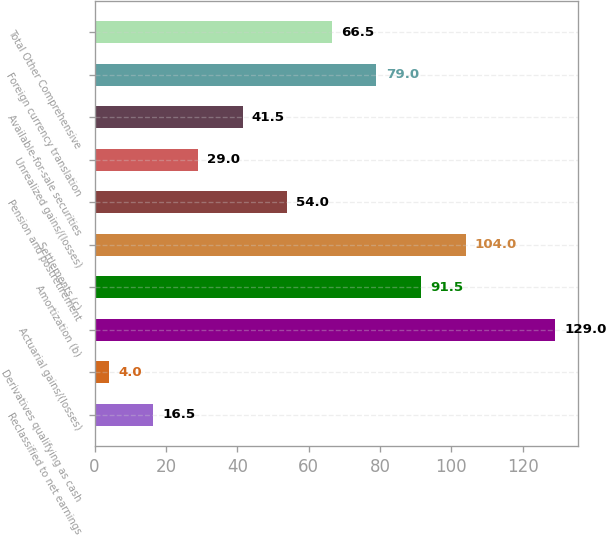Convert chart. <chart><loc_0><loc_0><loc_500><loc_500><bar_chart><fcel>Reclassified to net earnings<fcel>Derivatives qualifying as cash<fcel>Actuarial gains/(losses)<fcel>Amortization (b)<fcel>Settlements (c)<fcel>Pension and postretirement<fcel>Unrealized gains/(losses)<fcel>Available-for-sale securities<fcel>Foreign currency translation<fcel>Total Other Comprehensive<nl><fcel>16.5<fcel>4<fcel>129<fcel>91.5<fcel>104<fcel>54<fcel>29<fcel>41.5<fcel>79<fcel>66.5<nl></chart> 